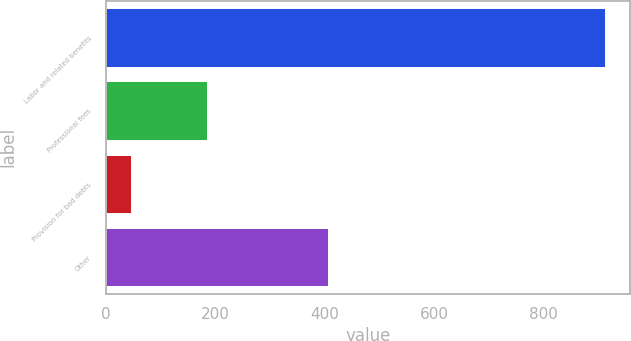Convert chart. <chart><loc_0><loc_0><loc_500><loc_500><bar_chart><fcel>Labor and related benefits<fcel>Professional fees<fcel>Provision for bad debts<fcel>Other<nl><fcel>913<fcel>185<fcel>47<fcel>406<nl></chart> 